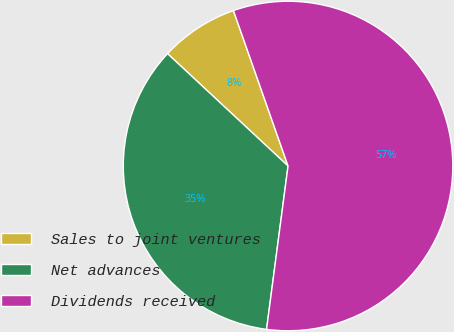Convert chart. <chart><loc_0><loc_0><loc_500><loc_500><pie_chart><fcel>Sales to joint ventures<fcel>Net advances<fcel>Dividends received<nl><fcel>7.68%<fcel>34.86%<fcel>57.46%<nl></chart> 